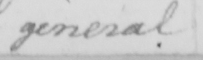Can you read and transcribe this handwriting? general 